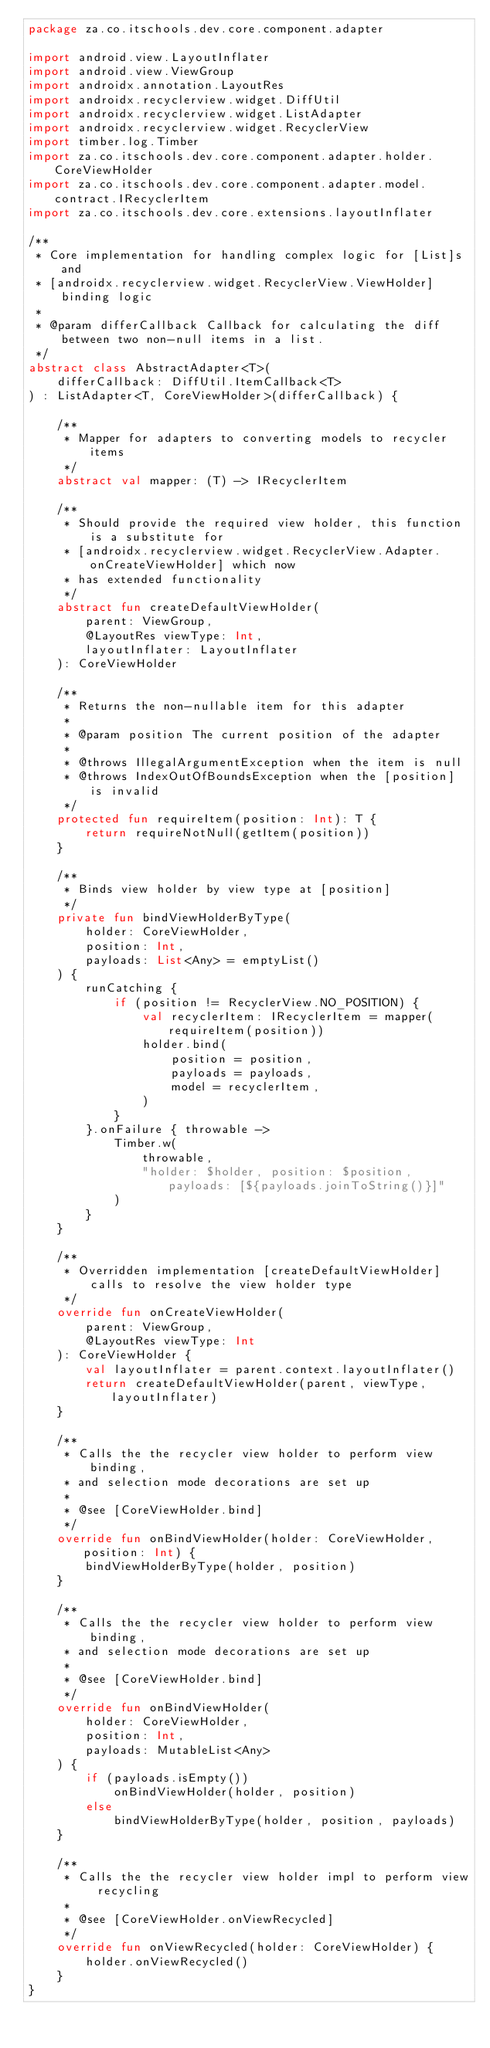<code> <loc_0><loc_0><loc_500><loc_500><_Kotlin_>package za.co.itschools.dev.core.component.adapter

import android.view.LayoutInflater
import android.view.ViewGroup
import androidx.annotation.LayoutRes
import androidx.recyclerview.widget.DiffUtil
import androidx.recyclerview.widget.ListAdapter
import androidx.recyclerview.widget.RecyclerView
import timber.log.Timber
import za.co.itschools.dev.core.component.adapter.holder.CoreViewHolder
import za.co.itschools.dev.core.component.adapter.model.contract.IRecyclerItem
import za.co.itschools.dev.core.extensions.layoutInflater

/**
 * Core implementation for handling complex logic for [List]s and
 * [androidx.recyclerview.widget.RecyclerView.ViewHolder] binding logic
 *
 * @param differCallback Callback for calculating the diff between two non-null items in a list.
 */
abstract class AbstractAdapter<T>(
    differCallback: DiffUtil.ItemCallback<T>
) : ListAdapter<T, CoreViewHolder>(differCallback) {

    /**
     * Mapper for adapters to converting models to recycler items
     */
    abstract val mapper: (T) -> IRecyclerItem

    /**
     * Should provide the required view holder, this function is a substitute for
     * [androidx.recyclerview.widget.RecyclerView.Adapter.onCreateViewHolder] which now
     * has extended functionality
     */
    abstract fun createDefaultViewHolder(
        parent: ViewGroup,
        @LayoutRes viewType: Int,
        layoutInflater: LayoutInflater
    ): CoreViewHolder

    /**
     * Returns the non-nullable item for this adapter
     *
     * @param position The current position of the adapter
     *
     * @throws IllegalArgumentException when the item is null
     * @throws IndexOutOfBoundsException when the [position] is invalid
     */
    protected fun requireItem(position: Int): T {
        return requireNotNull(getItem(position))
    }

    /**
     * Binds view holder by view type at [position]
     */
    private fun bindViewHolderByType(
        holder: CoreViewHolder,
        position: Int,
        payloads: List<Any> = emptyList()
    ) {
        runCatching {
            if (position != RecyclerView.NO_POSITION) {
                val recyclerItem: IRecyclerItem = mapper(requireItem(position))
                holder.bind(
                    position = position,
                    payloads = payloads,
                    model = recyclerItem,
                )
            }
        }.onFailure { throwable ->
            Timber.w(
                throwable,
                "holder: $holder, position: $position, payloads: [${payloads.joinToString()}]"
            )
        }
    }

    /**
     * Overridden implementation [createDefaultViewHolder] calls to resolve the view holder type
     */
    override fun onCreateViewHolder(
        parent: ViewGroup,
        @LayoutRes viewType: Int
    ): CoreViewHolder {
        val layoutInflater = parent.context.layoutInflater()
        return createDefaultViewHolder(parent, viewType, layoutInflater)
    }

    /**
     * Calls the the recycler view holder to perform view binding,
     * and selection mode decorations are set up
     *
     * @see [CoreViewHolder.bind]
     */
    override fun onBindViewHolder(holder: CoreViewHolder, position: Int) {
        bindViewHolderByType(holder, position)
    }

    /**
     * Calls the the recycler view holder to perform view binding,
     * and selection mode decorations are set up
     *
     * @see [CoreViewHolder.bind]
     */
    override fun onBindViewHolder(
        holder: CoreViewHolder,
        position: Int,
        payloads: MutableList<Any>
    ) {
        if (payloads.isEmpty())
            onBindViewHolder(holder, position)
        else
            bindViewHolderByType(holder, position, payloads)
    }

    /**
     * Calls the the recycler view holder impl to perform view recycling
     *
     * @see [CoreViewHolder.onViewRecycled]
     */
    override fun onViewRecycled(holder: CoreViewHolder) {
        holder.onViewRecycled()
    }
}</code> 